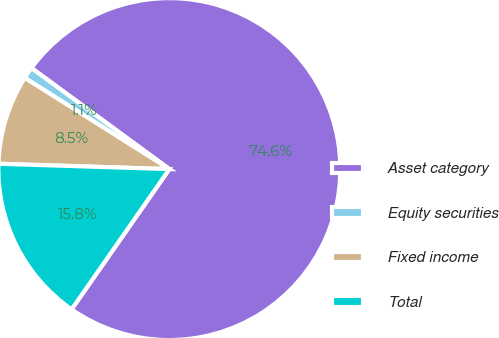<chart> <loc_0><loc_0><loc_500><loc_500><pie_chart><fcel>Asset category<fcel>Equity securities<fcel>Fixed income<fcel>Total<nl><fcel>74.62%<fcel>1.11%<fcel>8.46%<fcel>15.81%<nl></chart> 